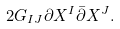<formula> <loc_0><loc_0><loc_500><loc_500>2 G _ { I J } \partial X ^ { I } \bar { \partial } X ^ { J } .</formula> 